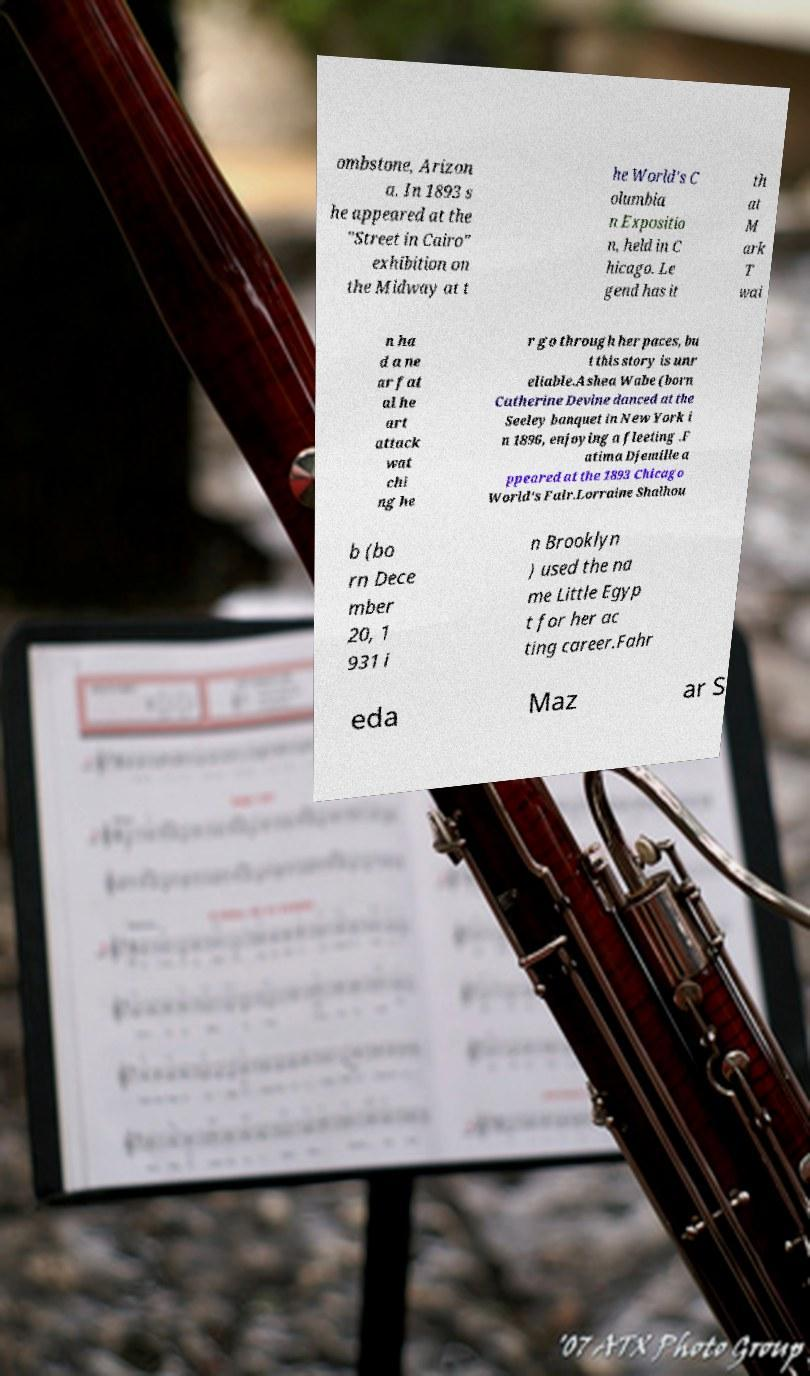I need the written content from this picture converted into text. Can you do that? ombstone, Arizon a. In 1893 s he appeared at the "Street in Cairo" exhibition on the Midway at t he World's C olumbia n Expositio n, held in C hicago. Le gend has it th at M ark T wai n ha d a ne ar fat al he art attack wat chi ng he r go through her paces, bu t this story is unr eliable.Ashea Wabe (born Catherine Devine danced at the Seeley banquet in New York i n 1896, enjoying a fleeting .F atima Djemille a ppeared at the 1893 Chicago World's Fair.Lorraine Shalhou b (bo rn Dece mber 20, 1 931 i n Brooklyn ) used the na me Little Egyp t for her ac ting career.Fahr eda Maz ar S 